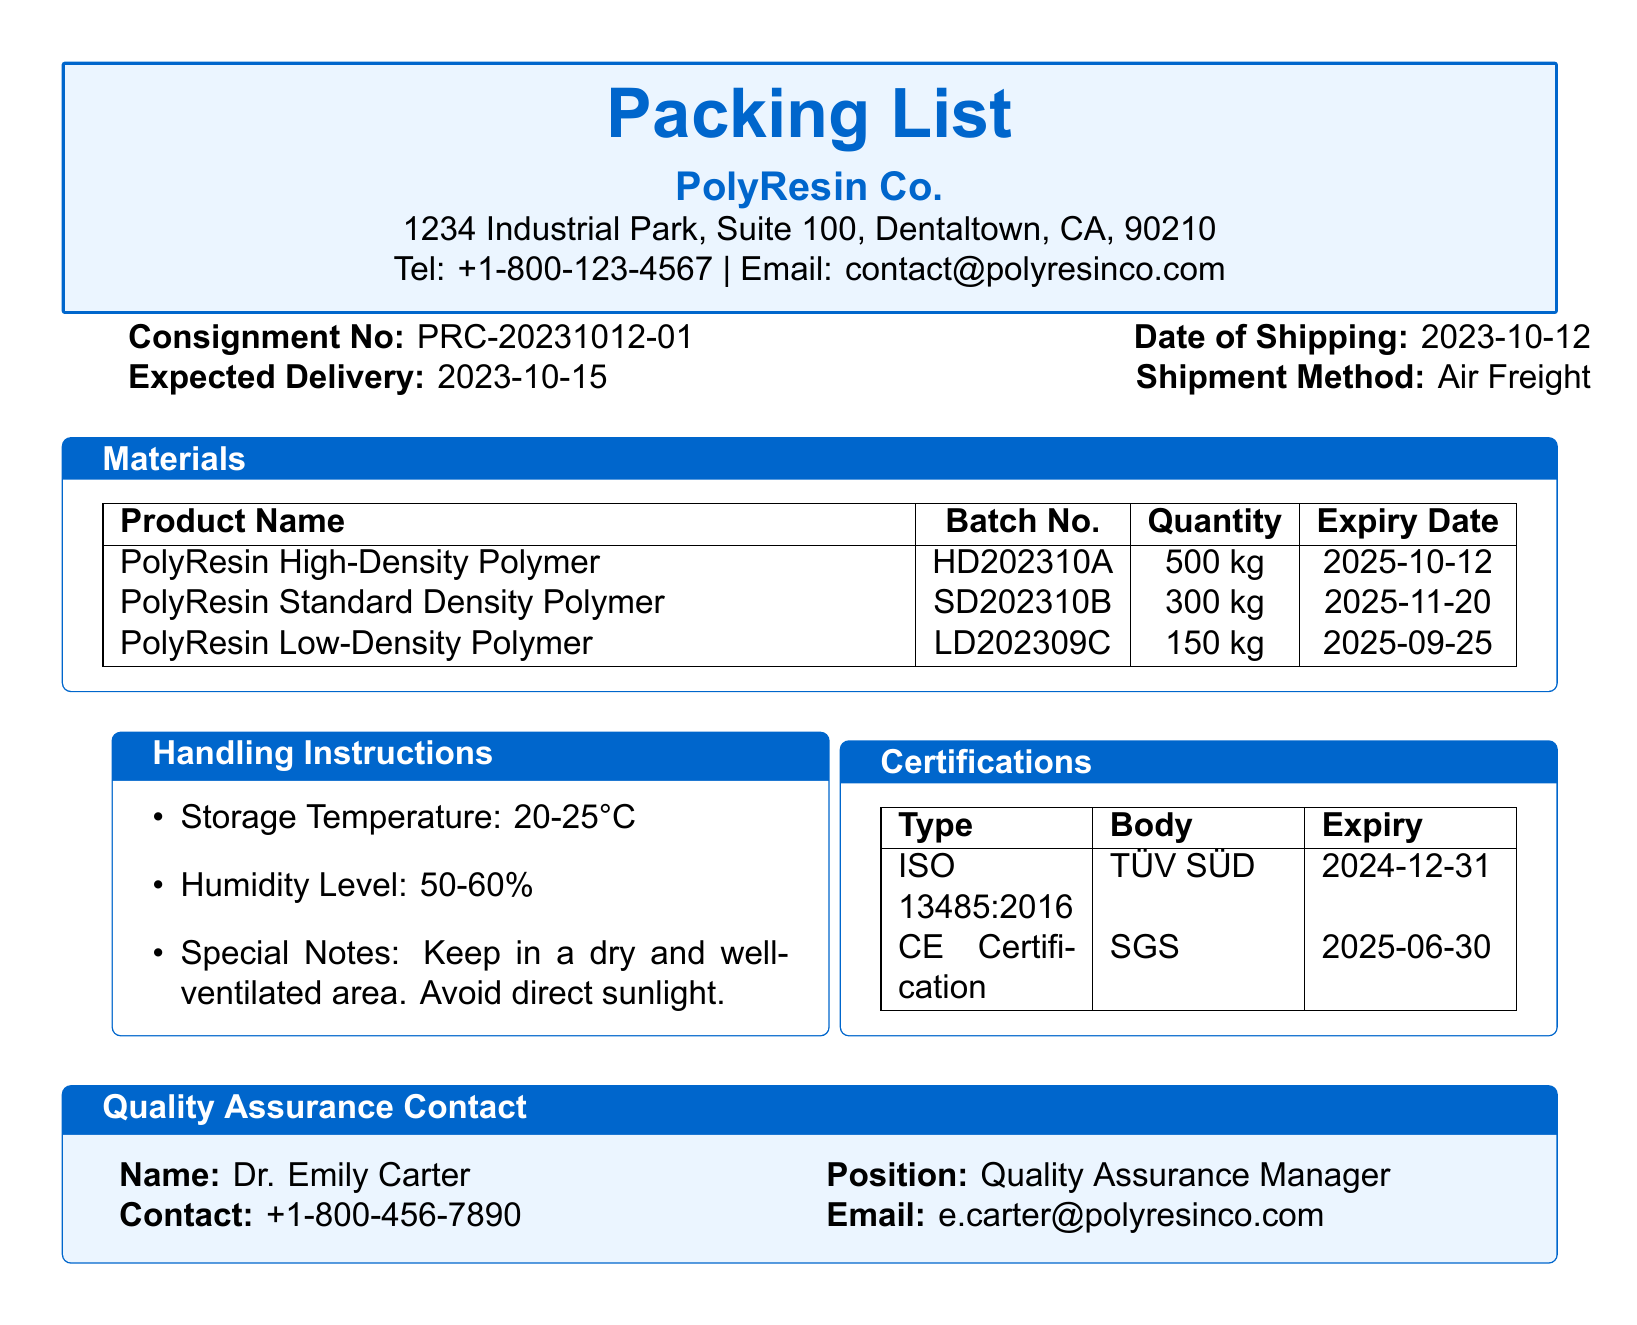What is the Consignment Number? The Consignment Number is listed in the document under the specific heading, which is PRC-20231012-01.
Answer: PRC-20231012-01 What is the Expiry Date of the PolyResin High-Density Polymer? The Expiry Date for this specific product is mentioned in the table under the expiry date column, which is 2025-10-12.
Answer: 2025-10-12 How many kilograms of PolyResin Low-Density Polymer are included? The quantity of this product is clearly stated in the document, which indicates 150 kg.
Answer: 150 kg What is the Shipment Method? The Shipment Method is specified in the top section of the packing list as 'Air Freight.'
Answer: Air Freight What is the contact email for Quality Assurance? The email for Quality Assurance contact is provided in the contact section, which is e.carter@polyresinco.com.
Answer: e.carter@polyresinco.com What are the storage temperature conditions for the materials? The document specifies the required storage temperature, which is between 20-25°C.
Answer: 20-25°C Which certification expires last? The expiry dates for the certifications are listed, and the ISO 13485:2016 certification expires on December 31, 2024, which is the last one.
Answer: 2024-12-31 How many kg of PolyResin Standard Density Polymer are shipped? The document clearly states the quantity of PolyResin Standard Density Polymer, which is 300 kg.
Answer: 300 kg What is the humidity level recommended for storage? The recommended humidity level is mentioned in the handling instructions, which is 50-60%.
Answer: 50-60% 